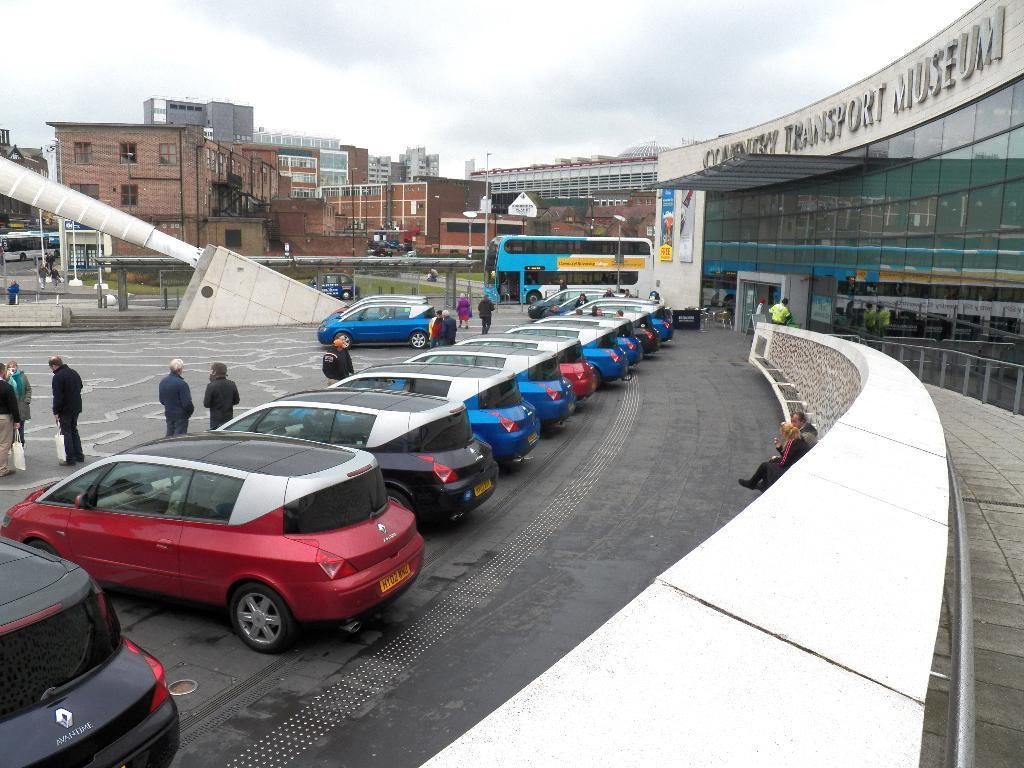Could you give a brief overview of what you see in this image? In this image we can see a few vehicles, there are some people, among them some people are carrying the bags, also we can see some buildings, windows, poles, boards, grass and a shed, in the background we can see the sky. 